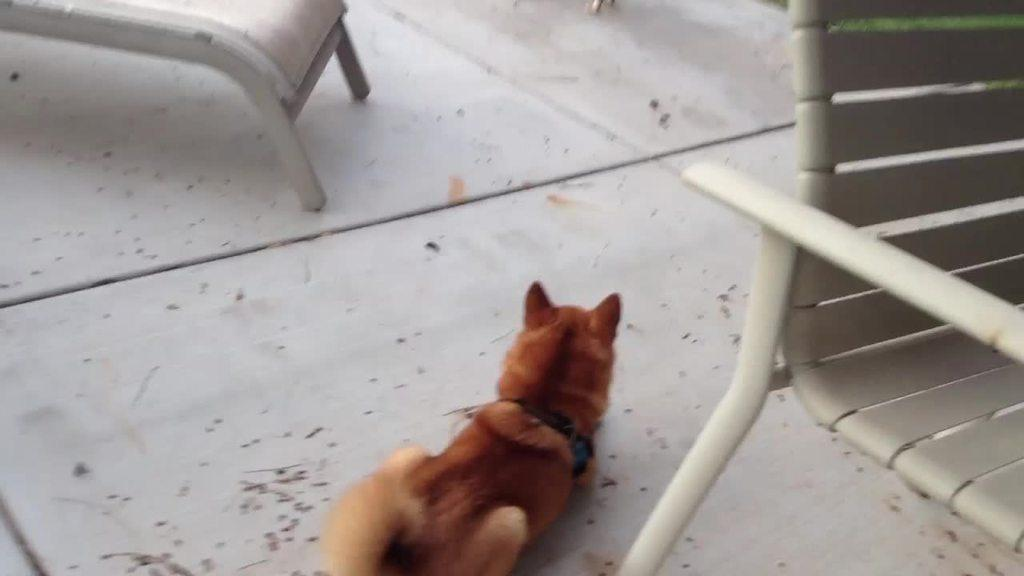What type of animal can be seen in the image? There is a brown color animal in the image. Where is the animal located? The animal is on the floor. What other objects are present in the image? There are chairs in the image. What type of joke is the animal telling in the image? There is no indication in the image that the animal is telling a joke, as animals do not have the ability to tell jokes. 